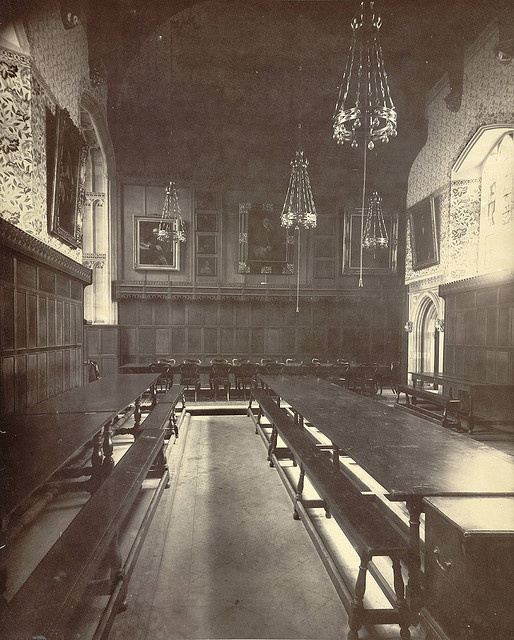Describe the objects in this image and their specific colors. I can see bench in black, gray, and maroon tones, bench in black, gray, maroon, and beige tones, dining table in black, gray, beige, and darkgray tones, dining table in black, gray, and maroon tones, and bench in black, gray, maroon, and darkgray tones in this image. 